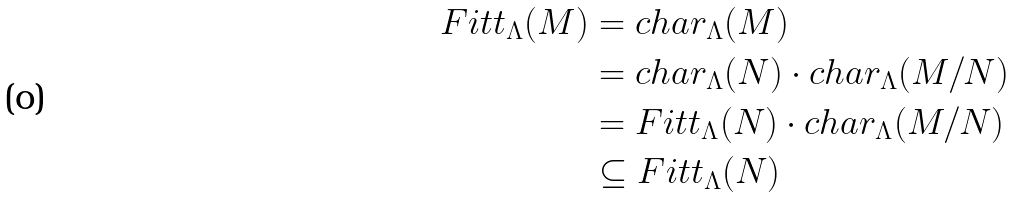Convert formula to latex. <formula><loc_0><loc_0><loc_500><loc_500>F i t t _ { \Lambda } ( M ) & = c h a r _ { \Lambda } ( M ) \\ & = c h a r _ { \Lambda } ( N ) \cdot c h a r _ { \Lambda } ( M / N ) \\ & = F i t t _ { \Lambda } ( N ) \cdot c h a r _ { \Lambda } ( M / N ) \\ & \subseteq F i t t _ { \Lambda } ( N )</formula> 